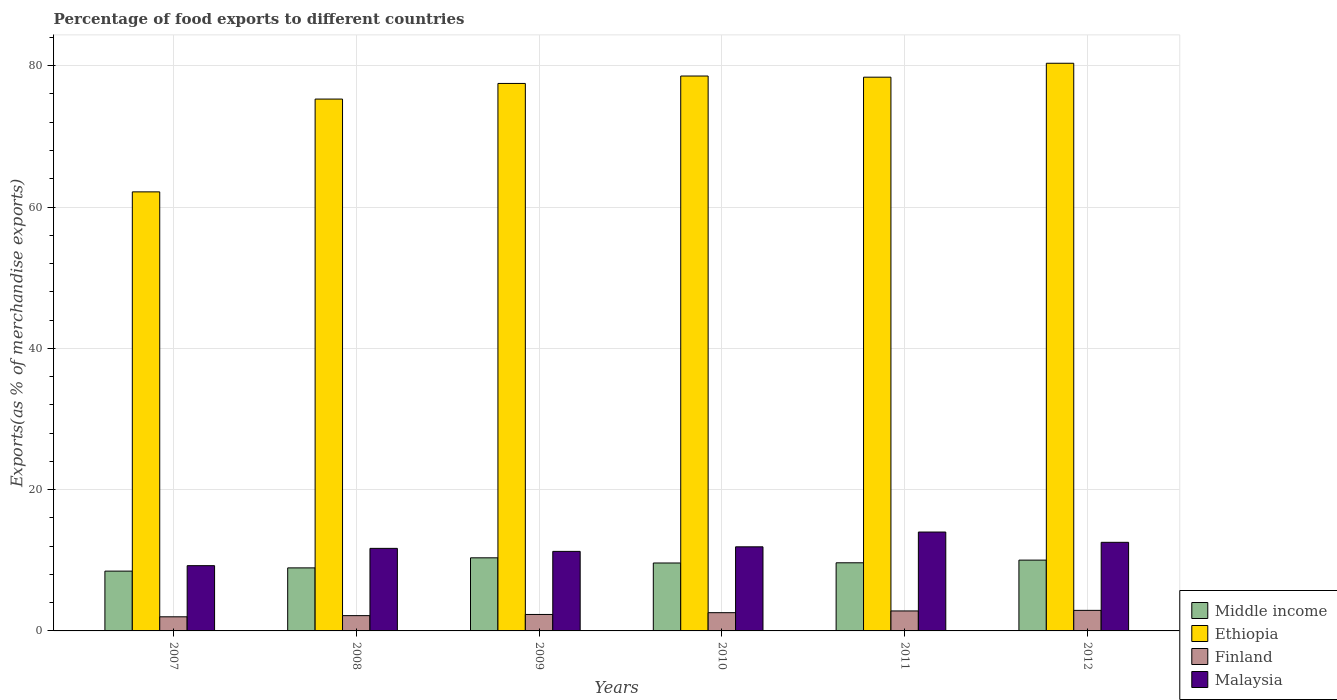How many different coloured bars are there?
Your answer should be compact. 4. How many groups of bars are there?
Your response must be concise. 6. Are the number of bars per tick equal to the number of legend labels?
Make the answer very short. Yes. Are the number of bars on each tick of the X-axis equal?
Keep it short and to the point. Yes. In how many cases, is the number of bars for a given year not equal to the number of legend labels?
Keep it short and to the point. 0. What is the percentage of exports to different countries in Malaysia in 2007?
Your response must be concise. 9.24. Across all years, what is the maximum percentage of exports to different countries in Malaysia?
Your answer should be very brief. 14. Across all years, what is the minimum percentage of exports to different countries in Middle income?
Provide a short and direct response. 8.46. What is the total percentage of exports to different countries in Finland in the graph?
Provide a short and direct response. 14.81. What is the difference between the percentage of exports to different countries in Finland in 2008 and that in 2009?
Keep it short and to the point. -0.17. What is the difference between the percentage of exports to different countries in Ethiopia in 2010 and the percentage of exports to different countries in Finland in 2009?
Ensure brevity in your answer.  76.21. What is the average percentage of exports to different countries in Malaysia per year?
Your answer should be compact. 11.77. In the year 2009, what is the difference between the percentage of exports to different countries in Finland and percentage of exports to different countries in Malaysia?
Your answer should be very brief. -8.93. What is the ratio of the percentage of exports to different countries in Malaysia in 2008 to that in 2011?
Offer a terse response. 0.83. Is the percentage of exports to different countries in Finland in 2008 less than that in 2009?
Your answer should be very brief. Yes. What is the difference between the highest and the second highest percentage of exports to different countries in Ethiopia?
Provide a succinct answer. 1.81. What is the difference between the highest and the lowest percentage of exports to different countries in Ethiopia?
Provide a short and direct response. 18.2. Is the sum of the percentage of exports to different countries in Finland in 2007 and 2009 greater than the maximum percentage of exports to different countries in Middle income across all years?
Provide a succinct answer. No. What does the 4th bar from the left in 2008 represents?
Keep it short and to the point. Malaysia. What does the 3rd bar from the right in 2011 represents?
Your answer should be very brief. Ethiopia. Are all the bars in the graph horizontal?
Your answer should be very brief. No. How many years are there in the graph?
Ensure brevity in your answer.  6. Are the values on the major ticks of Y-axis written in scientific E-notation?
Make the answer very short. No. Where does the legend appear in the graph?
Your response must be concise. Bottom right. How are the legend labels stacked?
Your response must be concise. Vertical. What is the title of the graph?
Your answer should be compact. Percentage of food exports to different countries. What is the label or title of the Y-axis?
Offer a terse response. Exports(as % of merchandise exports). What is the Exports(as % of merchandise exports) in Middle income in 2007?
Your response must be concise. 8.46. What is the Exports(as % of merchandise exports) of Ethiopia in 2007?
Offer a very short reply. 62.15. What is the Exports(as % of merchandise exports) of Finland in 2007?
Provide a short and direct response. 2. What is the Exports(as % of merchandise exports) in Malaysia in 2007?
Your answer should be very brief. 9.24. What is the Exports(as % of merchandise exports) of Middle income in 2008?
Make the answer very short. 8.92. What is the Exports(as % of merchandise exports) in Ethiopia in 2008?
Make the answer very short. 75.28. What is the Exports(as % of merchandise exports) of Finland in 2008?
Your answer should be compact. 2.16. What is the Exports(as % of merchandise exports) in Malaysia in 2008?
Make the answer very short. 11.68. What is the Exports(as % of merchandise exports) in Middle income in 2009?
Your answer should be very brief. 10.35. What is the Exports(as % of merchandise exports) of Ethiopia in 2009?
Give a very brief answer. 77.49. What is the Exports(as % of merchandise exports) in Finland in 2009?
Offer a terse response. 2.33. What is the Exports(as % of merchandise exports) in Malaysia in 2009?
Offer a terse response. 11.26. What is the Exports(as % of merchandise exports) in Middle income in 2010?
Provide a succinct answer. 9.62. What is the Exports(as % of merchandise exports) of Ethiopia in 2010?
Ensure brevity in your answer.  78.54. What is the Exports(as % of merchandise exports) in Finland in 2010?
Provide a short and direct response. 2.58. What is the Exports(as % of merchandise exports) in Malaysia in 2010?
Your response must be concise. 11.9. What is the Exports(as % of merchandise exports) in Middle income in 2011?
Provide a succinct answer. 9.64. What is the Exports(as % of merchandise exports) of Ethiopia in 2011?
Offer a terse response. 78.38. What is the Exports(as % of merchandise exports) in Finland in 2011?
Offer a very short reply. 2.83. What is the Exports(as % of merchandise exports) in Malaysia in 2011?
Your response must be concise. 14. What is the Exports(as % of merchandise exports) in Middle income in 2012?
Offer a very short reply. 10.02. What is the Exports(as % of merchandise exports) of Ethiopia in 2012?
Make the answer very short. 80.35. What is the Exports(as % of merchandise exports) in Finland in 2012?
Your answer should be very brief. 2.91. What is the Exports(as % of merchandise exports) of Malaysia in 2012?
Ensure brevity in your answer.  12.54. Across all years, what is the maximum Exports(as % of merchandise exports) in Middle income?
Your answer should be very brief. 10.35. Across all years, what is the maximum Exports(as % of merchandise exports) of Ethiopia?
Provide a short and direct response. 80.35. Across all years, what is the maximum Exports(as % of merchandise exports) in Finland?
Your response must be concise. 2.91. Across all years, what is the maximum Exports(as % of merchandise exports) in Malaysia?
Ensure brevity in your answer.  14. Across all years, what is the minimum Exports(as % of merchandise exports) of Middle income?
Provide a short and direct response. 8.46. Across all years, what is the minimum Exports(as % of merchandise exports) of Ethiopia?
Give a very brief answer. 62.15. Across all years, what is the minimum Exports(as % of merchandise exports) in Finland?
Offer a terse response. 2. Across all years, what is the minimum Exports(as % of merchandise exports) of Malaysia?
Offer a very short reply. 9.24. What is the total Exports(as % of merchandise exports) of Middle income in the graph?
Provide a succinct answer. 57.01. What is the total Exports(as % of merchandise exports) of Ethiopia in the graph?
Your response must be concise. 452.19. What is the total Exports(as % of merchandise exports) of Finland in the graph?
Give a very brief answer. 14.81. What is the total Exports(as % of merchandise exports) in Malaysia in the graph?
Keep it short and to the point. 70.62. What is the difference between the Exports(as % of merchandise exports) in Middle income in 2007 and that in 2008?
Provide a succinct answer. -0.46. What is the difference between the Exports(as % of merchandise exports) in Ethiopia in 2007 and that in 2008?
Provide a succinct answer. -13.13. What is the difference between the Exports(as % of merchandise exports) in Finland in 2007 and that in 2008?
Your answer should be very brief. -0.16. What is the difference between the Exports(as % of merchandise exports) of Malaysia in 2007 and that in 2008?
Give a very brief answer. -2.45. What is the difference between the Exports(as % of merchandise exports) in Middle income in 2007 and that in 2009?
Your answer should be compact. -1.88. What is the difference between the Exports(as % of merchandise exports) of Ethiopia in 2007 and that in 2009?
Keep it short and to the point. -15.35. What is the difference between the Exports(as % of merchandise exports) in Finland in 2007 and that in 2009?
Your answer should be compact. -0.33. What is the difference between the Exports(as % of merchandise exports) of Malaysia in 2007 and that in 2009?
Give a very brief answer. -2.02. What is the difference between the Exports(as % of merchandise exports) in Middle income in 2007 and that in 2010?
Your answer should be very brief. -1.15. What is the difference between the Exports(as % of merchandise exports) of Ethiopia in 2007 and that in 2010?
Provide a succinct answer. -16.4. What is the difference between the Exports(as % of merchandise exports) in Finland in 2007 and that in 2010?
Give a very brief answer. -0.58. What is the difference between the Exports(as % of merchandise exports) in Malaysia in 2007 and that in 2010?
Your response must be concise. -2.67. What is the difference between the Exports(as % of merchandise exports) in Middle income in 2007 and that in 2011?
Offer a very short reply. -1.18. What is the difference between the Exports(as % of merchandise exports) of Ethiopia in 2007 and that in 2011?
Provide a succinct answer. -16.23. What is the difference between the Exports(as % of merchandise exports) in Finland in 2007 and that in 2011?
Ensure brevity in your answer.  -0.83. What is the difference between the Exports(as % of merchandise exports) of Malaysia in 2007 and that in 2011?
Ensure brevity in your answer.  -4.76. What is the difference between the Exports(as % of merchandise exports) in Middle income in 2007 and that in 2012?
Your answer should be compact. -1.56. What is the difference between the Exports(as % of merchandise exports) of Ethiopia in 2007 and that in 2012?
Your answer should be compact. -18.2. What is the difference between the Exports(as % of merchandise exports) in Finland in 2007 and that in 2012?
Offer a terse response. -0.91. What is the difference between the Exports(as % of merchandise exports) in Malaysia in 2007 and that in 2012?
Provide a short and direct response. -3.3. What is the difference between the Exports(as % of merchandise exports) in Middle income in 2008 and that in 2009?
Your response must be concise. -1.42. What is the difference between the Exports(as % of merchandise exports) in Ethiopia in 2008 and that in 2009?
Make the answer very short. -2.21. What is the difference between the Exports(as % of merchandise exports) in Finland in 2008 and that in 2009?
Keep it short and to the point. -0.17. What is the difference between the Exports(as % of merchandise exports) in Malaysia in 2008 and that in 2009?
Offer a terse response. 0.43. What is the difference between the Exports(as % of merchandise exports) in Middle income in 2008 and that in 2010?
Ensure brevity in your answer.  -0.69. What is the difference between the Exports(as % of merchandise exports) in Ethiopia in 2008 and that in 2010?
Your answer should be compact. -3.26. What is the difference between the Exports(as % of merchandise exports) of Finland in 2008 and that in 2010?
Provide a succinct answer. -0.42. What is the difference between the Exports(as % of merchandise exports) of Malaysia in 2008 and that in 2010?
Keep it short and to the point. -0.22. What is the difference between the Exports(as % of merchandise exports) in Middle income in 2008 and that in 2011?
Provide a succinct answer. -0.72. What is the difference between the Exports(as % of merchandise exports) in Ethiopia in 2008 and that in 2011?
Keep it short and to the point. -3.1. What is the difference between the Exports(as % of merchandise exports) of Finland in 2008 and that in 2011?
Your answer should be compact. -0.66. What is the difference between the Exports(as % of merchandise exports) of Malaysia in 2008 and that in 2011?
Offer a very short reply. -2.31. What is the difference between the Exports(as % of merchandise exports) of Middle income in 2008 and that in 2012?
Keep it short and to the point. -1.1. What is the difference between the Exports(as % of merchandise exports) of Ethiopia in 2008 and that in 2012?
Your answer should be compact. -5.07. What is the difference between the Exports(as % of merchandise exports) of Finland in 2008 and that in 2012?
Give a very brief answer. -0.75. What is the difference between the Exports(as % of merchandise exports) in Malaysia in 2008 and that in 2012?
Your response must be concise. -0.86. What is the difference between the Exports(as % of merchandise exports) of Middle income in 2009 and that in 2010?
Provide a succinct answer. 0.73. What is the difference between the Exports(as % of merchandise exports) in Ethiopia in 2009 and that in 2010?
Offer a terse response. -1.05. What is the difference between the Exports(as % of merchandise exports) of Finland in 2009 and that in 2010?
Your answer should be compact. -0.25. What is the difference between the Exports(as % of merchandise exports) in Malaysia in 2009 and that in 2010?
Offer a very short reply. -0.65. What is the difference between the Exports(as % of merchandise exports) of Middle income in 2009 and that in 2011?
Make the answer very short. 0.7. What is the difference between the Exports(as % of merchandise exports) in Ethiopia in 2009 and that in 2011?
Provide a succinct answer. -0.89. What is the difference between the Exports(as % of merchandise exports) in Finland in 2009 and that in 2011?
Give a very brief answer. -0.5. What is the difference between the Exports(as % of merchandise exports) in Malaysia in 2009 and that in 2011?
Ensure brevity in your answer.  -2.74. What is the difference between the Exports(as % of merchandise exports) in Middle income in 2009 and that in 2012?
Ensure brevity in your answer.  0.33. What is the difference between the Exports(as % of merchandise exports) of Ethiopia in 2009 and that in 2012?
Give a very brief answer. -2.86. What is the difference between the Exports(as % of merchandise exports) of Finland in 2009 and that in 2012?
Keep it short and to the point. -0.58. What is the difference between the Exports(as % of merchandise exports) in Malaysia in 2009 and that in 2012?
Your response must be concise. -1.28. What is the difference between the Exports(as % of merchandise exports) in Middle income in 2010 and that in 2011?
Offer a terse response. -0.03. What is the difference between the Exports(as % of merchandise exports) of Ethiopia in 2010 and that in 2011?
Offer a very short reply. 0.16. What is the difference between the Exports(as % of merchandise exports) in Finland in 2010 and that in 2011?
Your answer should be compact. -0.25. What is the difference between the Exports(as % of merchandise exports) in Malaysia in 2010 and that in 2011?
Make the answer very short. -2.09. What is the difference between the Exports(as % of merchandise exports) of Middle income in 2010 and that in 2012?
Make the answer very short. -0.41. What is the difference between the Exports(as % of merchandise exports) of Ethiopia in 2010 and that in 2012?
Your answer should be very brief. -1.81. What is the difference between the Exports(as % of merchandise exports) of Finland in 2010 and that in 2012?
Your answer should be very brief. -0.33. What is the difference between the Exports(as % of merchandise exports) of Malaysia in 2010 and that in 2012?
Ensure brevity in your answer.  -0.64. What is the difference between the Exports(as % of merchandise exports) in Middle income in 2011 and that in 2012?
Keep it short and to the point. -0.38. What is the difference between the Exports(as % of merchandise exports) in Ethiopia in 2011 and that in 2012?
Your answer should be very brief. -1.97. What is the difference between the Exports(as % of merchandise exports) in Finland in 2011 and that in 2012?
Ensure brevity in your answer.  -0.08. What is the difference between the Exports(as % of merchandise exports) of Malaysia in 2011 and that in 2012?
Your answer should be very brief. 1.46. What is the difference between the Exports(as % of merchandise exports) of Middle income in 2007 and the Exports(as % of merchandise exports) of Ethiopia in 2008?
Provide a short and direct response. -66.82. What is the difference between the Exports(as % of merchandise exports) of Middle income in 2007 and the Exports(as % of merchandise exports) of Finland in 2008?
Your answer should be very brief. 6.3. What is the difference between the Exports(as % of merchandise exports) in Middle income in 2007 and the Exports(as % of merchandise exports) in Malaysia in 2008?
Give a very brief answer. -3.22. What is the difference between the Exports(as % of merchandise exports) in Ethiopia in 2007 and the Exports(as % of merchandise exports) in Finland in 2008?
Provide a short and direct response. 59.98. What is the difference between the Exports(as % of merchandise exports) in Ethiopia in 2007 and the Exports(as % of merchandise exports) in Malaysia in 2008?
Your answer should be very brief. 50.46. What is the difference between the Exports(as % of merchandise exports) of Finland in 2007 and the Exports(as % of merchandise exports) of Malaysia in 2008?
Offer a terse response. -9.69. What is the difference between the Exports(as % of merchandise exports) in Middle income in 2007 and the Exports(as % of merchandise exports) in Ethiopia in 2009?
Keep it short and to the point. -69.03. What is the difference between the Exports(as % of merchandise exports) of Middle income in 2007 and the Exports(as % of merchandise exports) of Finland in 2009?
Give a very brief answer. 6.14. What is the difference between the Exports(as % of merchandise exports) in Middle income in 2007 and the Exports(as % of merchandise exports) in Malaysia in 2009?
Offer a very short reply. -2.79. What is the difference between the Exports(as % of merchandise exports) of Ethiopia in 2007 and the Exports(as % of merchandise exports) of Finland in 2009?
Make the answer very short. 59.82. What is the difference between the Exports(as % of merchandise exports) of Ethiopia in 2007 and the Exports(as % of merchandise exports) of Malaysia in 2009?
Ensure brevity in your answer.  50.89. What is the difference between the Exports(as % of merchandise exports) of Finland in 2007 and the Exports(as % of merchandise exports) of Malaysia in 2009?
Provide a succinct answer. -9.26. What is the difference between the Exports(as % of merchandise exports) of Middle income in 2007 and the Exports(as % of merchandise exports) of Ethiopia in 2010?
Your answer should be compact. -70.08. What is the difference between the Exports(as % of merchandise exports) of Middle income in 2007 and the Exports(as % of merchandise exports) of Finland in 2010?
Keep it short and to the point. 5.88. What is the difference between the Exports(as % of merchandise exports) in Middle income in 2007 and the Exports(as % of merchandise exports) in Malaysia in 2010?
Ensure brevity in your answer.  -3.44. What is the difference between the Exports(as % of merchandise exports) in Ethiopia in 2007 and the Exports(as % of merchandise exports) in Finland in 2010?
Your answer should be very brief. 59.57. What is the difference between the Exports(as % of merchandise exports) of Ethiopia in 2007 and the Exports(as % of merchandise exports) of Malaysia in 2010?
Make the answer very short. 50.24. What is the difference between the Exports(as % of merchandise exports) of Finland in 2007 and the Exports(as % of merchandise exports) of Malaysia in 2010?
Offer a very short reply. -9.91. What is the difference between the Exports(as % of merchandise exports) in Middle income in 2007 and the Exports(as % of merchandise exports) in Ethiopia in 2011?
Provide a short and direct response. -69.91. What is the difference between the Exports(as % of merchandise exports) in Middle income in 2007 and the Exports(as % of merchandise exports) in Finland in 2011?
Make the answer very short. 5.64. What is the difference between the Exports(as % of merchandise exports) in Middle income in 2007 and the Exports(as % of merchandise exports) in Malaysia in 2011?
Offer a very short reply. -5.53. What is the difference between the Exports(as % of merchandise exports) in Ethiopia in 2007 and the Exports(as % of merchandise exports) in Finland in 2011?
Provide a short and direct response. 59.32. What is the difference between the Exports(as % of merchandise exports) of Ethiopia in 2007 and the Exports(as % of merchandise exports) of Malaysia in 2011?
Provide a succinct answer. 48.15. What is the difference between the Exports(as % of merchandise exports) in Finland in 2007 and the Exports(as % of merchandise exports) in Malaysia in 2011?
Provide a short and direct response. -12. What is the difference between the Exports(as % of merchandise exports) in Middle income in 2007 and the Exports(as % of merchandise exports) in Ethiopia in 2012?
Your response must be concise. -71.88. What is the difference between the Exports(as % of merchandise exports) of Middle income in 2007 and the Exports(as % of merchandise exports) of Finland in 2012?
Provide a short and direct response. 5.56. What is the difference between the Exports(as % of merchandise exports) in Middle income in 2007 and the Exports(as % of merchandise exports) in Malaysia in 2012?
Make the answer very short. -4.08. What is the difference between the Exports(as % of merchandise exports) of Ethiopia in 2007 and the Exports(as % of merchandise exports) of Finland in 2012?
Ensure brevity in your answer.  59.24. What is the difference between the Exports(as % of merchandise exports) of Ethiopia in 2007 and the Exports(as % of merchandise exports) of Malaysia in 2012?
Your answer should be compact. 49.61. What is the difference between the Exports(as % of merchandise exports) in Finland in 2007 and the Exports(as % of merchandise exports) in Malaysia in 2012?
Your response must be concise. -10.54. What is the difference between the Exports(as % of merchandise exports) in Middle income in 2008 and the Exports(as % of merchandise exports) in Ethiopia in 2009?
Provide a succinct answer. -68.57. What is the difference between the Exports(as % of merchandise exports) in Middle income in 2008 and the Exports(as % of merchandise exports) in Finland in 2009?
Provide a short and direct response. 6.59. What is the difference between the Exports(as % of merchandise exports) of Middle income in 2008 and the Exports(as % of merchandise exports) of Malaysia in 2009?
Provide a short and direct response. -2.34. What is the difference between the Exports(as % of merchandise exports) in Ethiopia in 2008 and the Exports(as % of merchandise exports) in Finland in 2009?
Offer a terse response. 72.95. What is the difference between the Exports(as % of merchandise exports) in Ethiopia in 2008 and the Exports(as % of merchandise exports) in Malaysia in 2009?
Keep it short and to the point. 64.02. What is the difference between the Exports(as % of merchandise exports) in Finland in 2008 and the Exports(as % of merchandise exports) in Malaysia in 2009?
Provide a short and direct response. -9.1. What is the difference between the Exports(as % of merchandise exports) in Middle income in 2008 and the Exports(as % of merchandise exports) in Ethiopia in 2010?
Offer a terse response. -69.62. What is the difference between the Exports(as % of merchandise exports) of Middle income in 2008 and the Exports(as % of merchandise exports) of Finland in 2010?
Make the answer very short. 6.34. What is the difference between the Exports(as % of merchandise exports) in Middle income in 2008 and the Exports(as % of merchandise exports) in Malaysia in 2010?
Your response must be concise. -2.98. What is the difference between the Exports(as % of merchandise exports) of Ethiopia in 2008 and the Exports(as % of merchandise exports) of Finland in 2010?
Your response must be concise. 72.7. What is the difference between the Exports(as % of merchandise exports) of Ethiopia in 2008 and the Exports(as % of merchandise exports) of Malaysia in 2010?
Ensure brevity in your answer.  63.38. What is the difference between the Exports(as % of merchandise exports) of Finland in 2008 and the Exports(as % of merchandise exports) of Malaysia in 2010?
Offer a terse response. -9.74. What is the difference between the Exports(as % of merchandise exports) in Middle income in 2008 and the Exports(as % of merchandise exports) in Ethiopia in 2011?
Your response must be concise. -69.45. What is the difference between the Exports(as % of merchandise exports) in Middle income in 2008 and the Exports(as % of merchandise exports) in Finland in 2011?
Give a very brief answer. 6.09. What is the difference between the Exports(as % of merchandise exports) in Middle income in 2008 and the Exports(as % of merchandise exports) in Malaysia in 2011?
Provide a short and direct response. -5.07. What is the difference between the Exports(as % of merchandise exports) of Ethiopia in 2008 and the Exports(as % of merchandise exports) of Finland in 2011?
Your answer should be compact. 72.45. What is the difference between the Exports(as % of merchandise exports) in Ethiopia in 2008 and the Exports(as % of merchandise exports) in Malaysia in 2011?
Your answer should be compact. 61.28. What is the difference between the Exports(as % of merchandise exports) in Finland in 2008 and the Exports(as % of merchandise exports) in Malaysia in 2011?
Your answer should be very brief. -11.83. What is the difference between the Exports(as % of merchandise exports) of Middle income in 2008 and the Exports(as % of merchandise exports) of Ethiopia in 2012?
Make the answer very short. -71.43. What is the difference between the Exports(as % of merchandise exports) of Middle income in 2008 and the Exports(as % of merchandise exports) of Finland in 2012?
Your answer should be compact. 6.01. What is the difference between the Exports(as % of merchandise exports) of Middle income in 2008 and the Exports(as % of merchandise exports) of Malaysia in 2012?
Ensure brevity in your answer.  -3.62. What is the difference between the Exports(as % of merchandise exports) of Ethiopia in 2008 and the Exports(as % of merchandise exports) of Finland in 2012?
Provide a succinct answer. 72.37. What is the difference between the Exports(as % of merchandise exports) in Ethiopia in 2008 and the Exports(as % of merchandise exports) in Malaysia in 2012?
Your answer should be very brief. 62.74. What is the difference between the Exports(as % of merchandise exports) of Finland in 2008 and the Exports(as % of merchandise exports) of Malaysia in 2012?
Your answer should be compact. -10.38. What is the difference between the Exports(as % of merchandise exports) in Middle income in 2009 and the Exports(as % of merchandise exports) in Ethiopia in 2010?
Keep it short and to the point. -68.2. What is the difference between the Exports(as % of merchandise exports) of Middle income in 2009 and the Exports(as % of merchandise exports) of Finland in 2010?
Your answer should be compact. 7.77. What is the difference between the Exports(as % of merchandise exports) in Middle income in 2009 and the Exports(as % of merchandise exports) in Malaysia in 2010?
Keep it short and to the point. -1.56. What is the difference between the Exports(as % of merchandise exports) of Ethiopia in 2009 and the Exports(as % of merchandise exports) of Finland in 2010?
Keep it short and to the point. 74.91. What is the difference between the Exports(as % of merchandise exports) in Ethiopia in 2009 and the Exports(as % of merchandise exports) in Malaysia in 2010?
Make the answer very short. 65.59. What is the difference between the Exports(as % of merchandise exports) of Finland in 2009 and the Exports(as % of merchandise exports) of Malaysia in 2010?
Your answer should be very brief. -9.58. What is the difference between the Exports(as % of merchandise exports) of Middle income in 2009 and the Exports(as % of merchandise exports) of Ethiopia in 2011?
Your response must be concise. -68.03. What is the difference between the Exports(as % of merchandise exports) of Middle income in 2009 and the Exports(as % of merchandise exports) of Finland in 2011?
Your answer should be very brief. 7.52. What is the difference between the Exports(as % of merchandise exports) of Middle income in 2009 and the Exports(as % of merchandise exports) of Malaysia in 2011?
Your answer should be very brief. -3.65. What is the difference between the Exports(as % of merchandise exports) of Ethiopia in 2009 and the Exports(as % of merchandise exports) of Finland in 2011?
Give a very brief answer. 74.66. What is the difference between the Exports(as % of merchandise exports) of Ethiopia in 2009 and the Exports(as % of merchandise exports) of Malaysia in 2011?
Your response must be concise. 63.49. What is the difference between the Exports(as % of merchandise exports) in Finland in 2009 and the Exports(as % of merchandise exports) in Malaysia in 2011?
Your answer should be compact. -11.67. What is the difference between the Exports(as % of merchandise exports) in Middle income in 2009 and the Exports(as % of merchandise exports) in Ethiopia in 2012?
Offer a terse response. -70. What is the difference between the Exports(as % of merchandise exports) in Middle income in 2009 and the Exports(as % of merchandise exports) in Finland in 2012?
Your answer should be very brief. 7.44. What is the difference between the Exports(as % of merchandise exports) in Middle income in 2009 and the Exports(as % of merchandise exports) in Malaysia in 2012?
Ensure brevity in your answer.  -2.19. What is the difference between the Exports(as % of merchandise exports) of Ethiopia in 2009 and the Exports(as % of merchandise exports) of Finland in 2012?
Give a very brief answer. 74.58. What is the difference between the Exports(as % of merchandise exports) in Ethiopia in 2009 and the Exports(as % of merchandise exports) in Malaysia in 2012?
Your response must be concise. 64.95. What is the difference between the Exports(as % of merchandise exports) in Finland in 2009 and the Exports(as % of merchandise exports) in Malaysia in 2012?
Your response must be concise. -10.21. What is the difference between the Exports(as % of merchandise exports) of Middle income in 2010 and the Exports(as % of merchandise exports) of Ethiopia in 2011?
Keep it short and to the point. -68.76. What is the difference between the Exports(as % of merchandise exports) in Middle income in 2010 and the Exports(as % of merchandise exports) in Finland in 2011?
Your answer should be compact. 6.79. What is the difference between the Exports(as % of merchandise exports) in Middle income in 2010 and the Exports(as % of merchandise exports) in Malaysia in 2011?
Your answer should be compact. -4.38. What is the difference between the Exports(as % of merchandise exports) in Ethiopia in 2010 and the Exports(as % of merchandise exports) in Finland in 2011?
Provide a succinct answer. 75.71. What is the difference between the Exports(as % of merchandise exports) of Ethiopia in 2010 and the Exports(as % of merchandise exports) of Malaysia in 2011?
Keep it short and to the point. 64.54. What is the difference between the Exports(as % of merchandise exports) of Finland in 2010 and the Exports(as % of merchandise exports) of Malaysia in 2011?
Provide a succinct answer. -11.42. What is the difference between the Exports(as % of merchandise exports) of Middle income in 2010 and the Exports(as % of merchandise exports) of Ethiopia in 2012?
Make the answer very short. -70.73. What is the difference between the Exports(as % of merchandise exports) in Middle income in 2010 and the Exports(as % of merchandise exports) in Finland in 2012?
Offer a terse response. 6.71. What is the difference between the Exports(as % of merchandise exports) of Middle income in 2010 and the Exports(as % of merchandise exports) of Malaysia in 2012?
Ensure brevity in your answer.  -2.93. What is the difference between the Exports(as % of merchandise exports) of Ethiopia in 2010 and the Exports(as % of merchandise exports) of Finland in 2012?
Make the answer very short. 75.63. What is the difference between the Exports(as % of merchandise exports) of Ethiopia in 2010 and the Exports(as % of merchandise exports) of Malaysia in 2012?
Give a very brief answer. 66. What is the difference between the Exports(as % of merchandise exports) of Finland in 2010 and the Exports(as % of merchandise exports) of Malaysia in 2012?
Your answer should be compact. -9.96. What is the difference between the Exports(as % of merchandise exports) of Middle income in 2011 and the Exports(as % of merchandise exports) of Ethiopia in 2012?
Give a very brief answer. -70.71. What is the difference between the Exports(as % of merchandise exports) in Middle income in 2011 and the Exports(as % of merchandise exports) in Finland in 2012?
Provide a succinct answer. 6.73. What is the difference between the Exports(as % of merchandise exports) in Middle income in 2011 and the Exports(as % of merchandise exports) in Malaysia in 2012?
Offer a very short reply. -2.9. What is the difference between the Exports(as % of merchandise exports) of Ethiopia in 2011 and the Exports(as % of merchandise exports) of Finland in 2012?
Keep it short and to the point. 75.47. What is the difference between the Exports(as % of merchandise exports) of Ethiopia in 2011 and the Exports(as % of merchandise exports) of Malaysia in 2012?
Give a very brief answer. 65.84. What is the difference between the Exports(as % of merchandise exports) in Finland in 2011 and the Exports(as % of merchandise exports) in Malaysia in 2012?
Provide a short and direct response. -9.71. What is the average Exports(as % of merchandise exports) in Middle income per year?
Offer a very short reply. 9.5. What is the average Exports(as % of merchandise exports) of Ethiopia per year?
Keep it short and to the point. 75.36. What is the average Exports(as % of merchandise exports) in Finland per year?
Keep it short and to the point. 2.47. What is the average Exports(as % of merchandise exports) of Malaysia per year?
Provide a succinct answer. 11.77. In the year 2007, what is the difference between the Exports(as % of merchandise exports) of Middle income and Exports(as % of merchandise exports) of Ethiopia?
Give a very brief answer. -53.68. In the year 2007, what is the difference between the Exports(as % of merchandise exports) of Middle income and Exports(as % of merchandise exports) of Finland?
Your response must be concise. 6.47. In the year 2007, what is the difference between the Exports(as % of merchandise exports) in Middle income and Exports(as % of merchandise exports) in Malaysia?
Offer a very short reply. -0.77. In the year 2007, what is the difference between the Exports(as % of merchandise exports) of Ethiopia and Exports(as % of merchandise exports) of Finland?
Your answer should be compact. 60.15. In the year 2007, what is the difference between the Exports(as % of merchandise exports) in Ethiopia and Exports(as % of merchandise exports) in Malaysia?
Offer a terse response. 52.91. In the year 2007, what is the difference between the Exports(as % of merchandise exports) in Finland and Exports(as % of merchandise exports) in Malaysia?
Your response must be concise. -7.24. In the year 2008, what is the difference between the Exports(as % of merchandise exports) of Middle income and Exports(as % of merchandise exports) of Ethiopia?
Provide a short and direct response. -66.36. In the year 2008, what is the difference between the Exports(as % of merchandise exports) of Middle income and Exports(as % of merchandise exports) of Finland?
Make the answer very short. 6.76. In the year 2008, what is the difference between the Exports(as % of merchandise exports) in Middle income and Exports(as % of merchandise exports) in Malaysia?
Provide a short and direct response. -2.76. In the year 2008, what is the difference between the Exports(as % of merchandise exports) of Ethiopia and Exports(as % of merchandise exports) of Finland?
Ensure brevity in your answer.  73.12. In the year 2008, what is the difference between the Exports(as % of merchandise exports) in Ethiopia and Exports(as % of merchandise exports) in Malaysia?
Provide a succinct answer. 63.6. In the year 2008, what is the difference between the Exports(as % of merchandise exports) of Finland and Exports(as % of merchandise exports) of Malaysia?
Offer a very short reply. -9.52. In the year 2009, what is the difference between the Exports(as % of merchandise exports) of Middle income and Exports(as % of merchandise exports) of Ethiopia?
Give a very brief answer. -67.14. In the year 2009, what is the difference between the Exports(as % of merchandise exports) of Middle income and Exports(as % of merchandise exports) of Finland?
Your answer should be compact. 8.02. In the year 2009, what is the difference between the Exports(as % of merchandise exports) in Middle income and Exports(as % of merchandise exports) in Malaysia?
Make the answer very short. -0.91. In the year 2009, what is the difference between the Exports(as % of merchandise exports) of Ethiopia and Exports(as % of merchandise exports) of Finland?
Offer a terse response. 75.16. In the year 2009, what is the difference between the Exports(as % of merchandise exports) in Ethiopia and Exports(as % of merchandise exports) in Malaysia?
Your response must be concise. 66.23. In the year 2009, what is the difference between the Exports(as % of merchandise exports) in Finland and Exports(as % of merchandise exports) in Malaysia?
Keep it short and to the point. -8.93. In the year 2010, what is the difference between the Exports(as % of merchandise exports) of Middle income and Exports(as % of merchandise exports) of Ethiopia?
Offer a terse response. -68.93. In the year 2010, what is the difference between the Exports(as % of merchandise exports) in Middle income and Exports(as % of merchandise exports) in Finland?
Give a very brief answer. 7.03. In the year 2010, what is the difference between the Exports(as % of merchandise exports) of Middle income and Exports(as % of merchandise exports) of Malaysia?
Provide a short and direct response. -2.29. In the year 2010, what is the difference between the Exports(as % of merchandise exports) of Ethiopia and Exports(as % of merchandise exports) of Finland?
Your response must be concise. 75.96. In the year 2010, what is the difference between the Exports(as % of merchandise exports) of Ethiopia and Exports(as % of merchandise exports) of Malaysia?
Offer a very short reply. 66.64. In the year 2010, what is the difference between the Exports(as % of merchandise exports) in Finland and Exports(as % of merchandise exports) in Malaysia?
Provide a succinct answer. -9.32. In the year 2011, what is the difference between the Exports(as % of merchandise exports) of Middle income and Exports(as % of merchandise exports) of Ethiopia?
Offer a terse response. -68.73. In the year 2011, what is the difference between the Exports(as % of merchandise exports) in Middle income and Exports(as % of merchandise exports) in Finland?
Your response must be concise. 6.82. In the year 2011, what is the difference between the Exports(as % of merchandise exports) of Middle income and Exports(as % of merchandise exports) of Malaysia?
Provide a short and direct response. -4.35. In the year 2011, what is the difference between the Exports(as % of merchandise exports) of Ethiopia and Exports(as % of merchandise exports) of Finland?
Provide a short and direct response. 75.55. In the year 2011, what is the difference between the Exports(as % of merchandise exports) of Ethiopia and Exports(as % of merchandise exports) of Malaysia?
Your response must be concise. 64.38. In the year 2011, what is the difference between the Exports(as % of merchandise exports) in Finland and Exports(as % of merchandise exports) in Malaysia?
Provide a succinct answer. -11.17. In the year 2012, what is the difference between the Exports(as % of merchandise exports) of Middle income and Exports(as % of merchandise exports) of Ethiopia?
Give a very brief answer. -70.33. In the year 2012, what is the difference between the Exports(as % of merchandise exports) of Middle income and Exports(as % of merchandise exports) of Finland?
Keep it short and to the point. 7.11. In the year 2012, what is the difference between the Exports(as % of merchandise exports) of Middle income and Exports(as % of merchandise exports) of Malaysia?
Keep it short and to the point. -2.52. In the year 2012, what is the difference between the Exports(as % of merchandise exports) of Ethiopia and Exports(as % of merchandise exports) of Finland?
Your answer should be very brief. 77.44. In the year 2012, what is the difference between the Exports(as % of merchandise exports) of Ethiopia and Exports(as % of merchandise exports) of Malaysia?
Ensure brevity in your answer.  67.81. In the year 2012, what is the difference between the Exports(as % of merchandise exports) in Finland and Exports(as % of merchandise exports) in Malaysia?
Offer a very short reply. -9.63. What is the ratio of the Exports(as % of merchandise exports) in Middle income in 2007 to that in 2008?
Your response must be concise. 0.95. What is the ratio of the Exports(as % of merchandise exports) of Ethiopia in 2007 to that in 2008?
Offer a very short reply. 0.83. What is the ratio of the Exports(as % of merchandise exports) in Finland in 2007 to that in 2008?
Your response must be concise. 0.92. What is the ratio of the Exports(as % of merchandise exports) of Malaysia in 2007 to that in 2008?
Make the answer very short. 0.79. What is the ratio of the Exports(as % of merchandise exports) in Middle income in 2007 to that in 2009?
Ensure brevity in your answer.  0.82. What is the ratio of the Exports(as % of merchandise exports) of Ethiopia in 2007 to that in 2009?
Your answer should be very brief. 0.8. What is the ratio of the Exports(as % of merchandise exports) in Finland in 2007 to that in 2009?
Offer a very short reply. 0.86. What is the ratio of the Exports(as % of merchandise exports) of Malaysia in 2007 to that in 2009?
Make the answer very short. 0.82. What is the ratio of the Exports(as % of merchandise exports) of Middle income in 2007 to that in 2010?
Your answer should be very brief. 0.88. What is the ratio of the Exports(as % of merchandise exports) in Ethiopia in 2007 to that in 2010?
Provide a succinct answer. 0.79. What is the ratio of the Exports(as % of merchandise exports) of Finland in 2007 to that in 2010?
Your response must be concise. 0.77. What is the ratio of the Exports(as % of merchandise exports) of Malaysia in 2007 to that in 2010?
Offer a terse response. 0.78. What is the ratio of the Exports(as % of merchandise exports) in Middle income in 2007 to that in 2011?
Give a very brief answer. 0.88. What is the ratio of the Exports(as % of merchandise exports) of Ethiopia in 2007 to that in 2011?
Your answer should be very brief. 0.79. What is the ratio of the Exports(as % of merchandise exports) of Finland in 2007 to that in 2011?
Offer a very short reply. 0.71. What is the ratio of the Exports(as % of merchandise exports) of Malaysia in 2007 to that in 2011?
Make the answer very short. 0.66. What is the ratio of the Exports(as % of merchandise exports) of Middle income in 2007 to that in 2012?
Keep it short and to the point. 0.84. What is the ratio of the Exports(as % of merchandise exports) of Ethiopia in 2007 to that in 2012?
Your answer should be compact. 0.77. What is the ratio of the Exports(as % of merchandise exports) in Finland in 2007 to that in 2012?
Keep it short and to the point. 0.69. What is the ratio of the Exports(as % of merchandise exports) in Malaysia in 2007 to that in 2012?
Provide a short and direct response. 0.74. What is the ratio of the Exports(as % of merchandise exports) in Middle income in 2008 to that in 2009?
Offer a very short reply. 0.86. What is the ratio of the Exports(as % of merchandise exports) of Ethiopia in 2008 to that in 2009?
Keep it short and to the point. 0.97. What is the ratio of the Exports(as % of merchandise exports) in Finland in 2008 to that in 2009?
Offer a very short reply. 0.93. What is the ratio of the Exports(as % of merchandise exports) in Malaysia in 2008 to that in 2009?
Your response must be concise. 1.04. What is the ratio of the Exports(as % of merchandise exports) in Middle income in 2008 to that in 2010?
Make the answer very short. 0.93. What is the ratio of the Exports(as % of merchandise exports) in Ethiopia in 2008 to that in 2010?
Provide a succinct answer. 0.96. What is the ratio of the Exports(as % of merchandise exports) of Finland in 2008 to that in 2010?
Ensure brevity in your answer.  0.84. What is the ratio of the Exports(as % of merchandise exports) of Malaysia in 2008 to that in 2010?
Provide a succinct answer. 0.98. What is the ratio of the Exports(as % of merchandise exports) of Middle income in 2008 to that in 2011?
Ensure brevity in your answer.  0.93. What is the ratio of the Exports(as % of merchandise exports) of Ethiopia in 2008 to that in 2011?
Offer a very short reply. 0.96. What is the ratio of the Exports(as % of merchandise exports) of Finland in 2008 to that in 2011?
Keep it short and to the point. 0.77. What is the ratio of the Exports(as % of merchandise exports) in Malaysia in 2008 to that in 2011?
Provide a succinct answer. 0.83. What is the ratio of the Exports(as % of merchandise exports) of Middle income in 2008 to that in 2012?
Make the answer very short. 0.89. What is the ratio of the Exports(as % of merchandise exports) in Ethiopia in 2008 to that in 2012?
Keep it short and to the point. 0.94. What is the ratio of the Exports(as % of merchandise exports) of Finland in 2008 to that in 2012?
Provide a succinct answer. 0.74. What is the ratio of the Exports(as % of merchandise exports) of Malaysia in 2008 to that in 2012?
Your response must be concise. 0.93. What is the ratio of the Exports(as % of merchandise exports) of Middle income in 2009 to that in 2010?
Give a very brief answer. 1.08. What is the ratio of the Exports(as % of merchandise exports) in Ethiopia in 2009 to that in 2010?
Your answer should be compact. 0.99. What is the ratio of the Exports(as % of merchandise exports) in Finland in 2009 to that in 2010?
Your response must be concise. 0.9. What is the ratio of the Exports(as % of merchandise exports) of Malaysia in 2009 to that in 2010?
Provide a succinct answer. 0.95. What is the ratio of the Exports(as % of merchandise exports) of Middle income in 2009 to that in 2011?
Your response must be concise. 1.07. What is the ratio of the Exports(as % of merchandise exports) of Ethiopia in 2009 to that in 2011?
Keep it short and to the point. 0.99. What is the ratio of the Exports(as % of merchandise exports) of Finland in 2009 to that in 2011?
Your response must be concise. 0.82. What is the ratio of the Exports(as % of merchandise exports) in Malaysia in 2009 to that in 2011?
Keep it short and to the point. 0.8. What is the ratio of the Exports(as % of merchandise exports) in Middle income in 2009 to that in 2012?
Your answer should be compact. 1.03. What is the ratio of the Exports(as % of merchandise exports) of Ethiopia in 2009 to that in 2012?
Ensure brevity in your answer.  0.96. What is the ratio of the Exports(as % of merchandise exports) of Finland in 2009 to that in 2012?
Offer a terse response. 0.8. What is the ratio of the Exports(as % of merchandise exports) of Malaysia in 2009 to that in 2012?
Give a very brief answer. 0.9. What is the ratio of the Exports(as % of merchandise exports) of Finland in 2010 to that in 2011?
Give a very brief answer. 0.91. What is the ratio of the Exports(as % of merchandise exports) in Malaysia in 2010 to that in 2011?
Keep it short and to the point. 0.85. What is the ratio of the Exports(as % of merchandise exports) in Middle income in 2010 to that in 2012?
Give a very brief answer. 0.96. What is the ratio of the Exports(as % of merchandise exports) of Ethiopia in 2010 to that in 2012?
Make the answer very short. 0.98. What is the ratio of the Exports(as % of merchandise exports) in Finland in 2010 to that in 2012?
Provide a short and direct response. 0.89. What is the ratio of the Exports(as % of merchandise exports) in Malaysia in 2010 to that in 2012?
Your answer should be compact. 0.95. What is the ratio of the Exports(as % of merchandise exports) of Middle income in 2011 to that in 2012?
Your answer should be compact. 0.96. What is the ratio of the Exports(as % of merchandise exports) in Ethiopia in 2011 to that in 2012?
Give a very brief answer. 0.98. What is the ratio of the Exports(as % of merchandise exports) of Finland in 2011 to that in 2012?
Make the answer very short. 0.97. What is the ratio of the Exports(as % of merchandise exports) of Malaysia in 2011 to that in 2012?
Your response must be concise. 1.12. What is the difference between the highest and the second highest Exports(as % of merchandise exports) in Middle income?
Your response must be concise. 0.33. What is the difference between the highest and the second highest Exports(as % of merchandise exports) in Ethiopia?
Provide a succinct answer. 1.81. What is the difference between the highest and the second highest Exports(as % of merchandise exports) of Finland?
Your response must be concise. 0.08. What is the difference between the highest and the second highest Exports(as % of merchandise exports) of Malaysia?
Give a very brief answer. 1.46. What is the difference between the highest and the lowest Exports(as % of merchandise exports) of Middle income?
Your answer should be compact. 1.88. What is the difference between the highest and the lowest Exports(as % of merchandise exports) of Ethiopia?
Offer a very short reply. 18.2. What is the difference between the highest and the lowest Exports(as % of merchandise exports) in Finland?
Offer a terse response. 0.91. What is the difference between the highest and the lowest Exports(as % of merchandise exports) in Malaysia?
Your answer should be very brief. 4.76. 